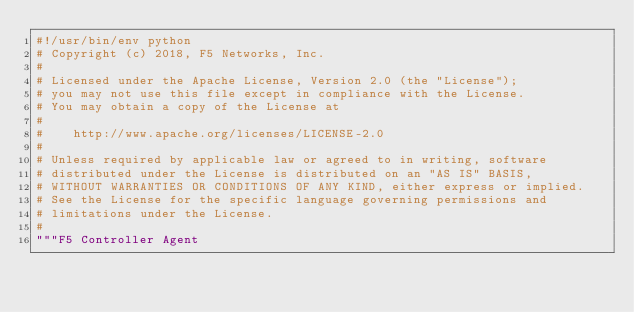Convert code to text. <code><loc_0><loc_0><loc_500><loc_500><_Python_>#!/usr/bin/env python
# Copyright (c) 2018, F5 Networks, Inc.
#
# Licensed under the Apache License, Version 2.0 (the "License");
# you may not use this file except in compliance with the License.
# You may obtain a copy of the License at
#
#    http://www.apache.org/licenses/LICENSE-2.0
#
# Unless required by applicable law or agreed to in writing, software
# distributed under the License is distributed on an "AS IS" BASIS,
# WITHOUT WARRANTIES OR CONDITIONS OF ANY KIND, either express or implied.
# See the License for the specific language governing permissions and
# limitations under the License.
#
"""F5 Controller Agent</code> 